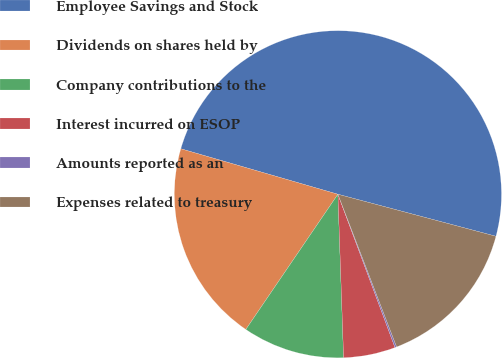<chart> <loc_0><loc_0><loc_500><loc_500><pie_chart><fcel>Employee Savings and Stock<fcel>Dividends on shares held by<fcel>Company contributions to the<fcel>Interest incurred on ESOP<fcel>Amounts reported as an<fcel>Expenses related to treasury<nl><fcel>49.65%<fcel>19.97%<fcel>10.07%<fcel>5.12%<fcel>0.17%<fcel>15.02%<nl></chart> 